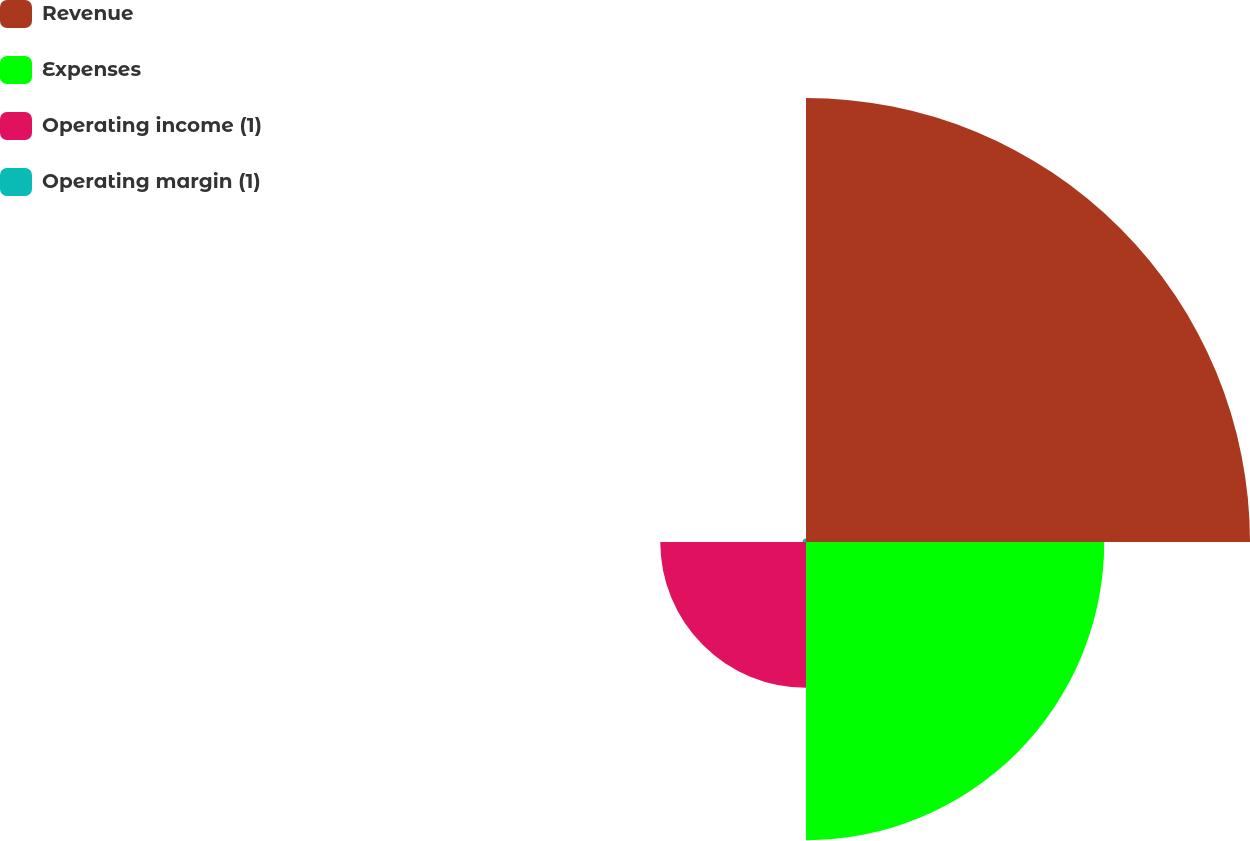Convert chart to OTSL. <chart><loc_0><loc_0><loc_500><loc_500><pie_chart><fcel>Revenue<fcel>Expenses<fcel>Operating income (1)<fcel>Operating margin (1)<nl><fcel>49.81%<fcel>33.46%<fcel>16.35%<fcel>0.38%<nl></chart> 